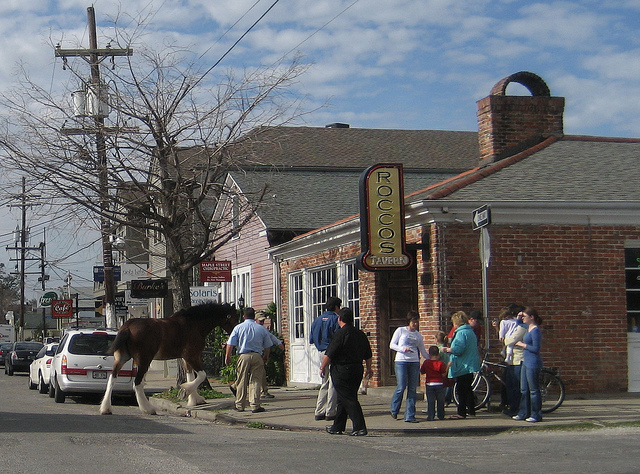<image>What church is this? I don't know what church this is. It might be "rocco's", a protestant or christian church, or there might not be a church at all. What church is this? I don't know which church it is. It can be 'Rocco's', 'Protestant', 'Christian', or none. 